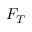Convert formula to latex. <formula><loc_0><loc_0><loc_500><loc_500>F _ { T }</formula> 